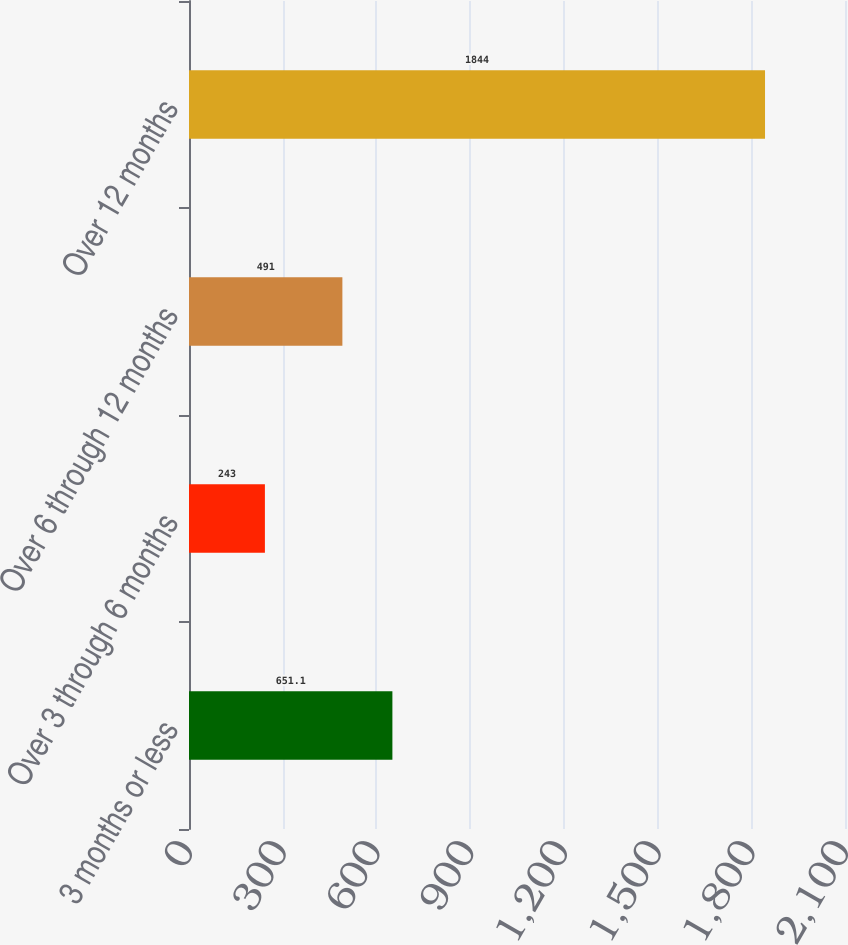Convert chart. <chart><loc_0><loc_0><loc_500><loc_500><bar_chart><fcel>3 months or less<fcel>Over 3 through 6 months<fcel>Over 6 through 12 months<fcel>Over 12 months<nl><fcel>651.1<fcel>243<fcel>491<fcel>1844<nl></chart> 